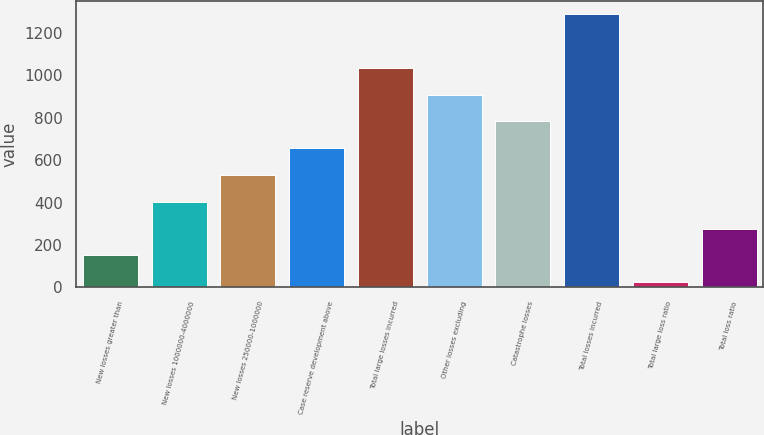<chart> <loc_0><loc_0><loc_500><loc_500><bar_chart><fcel>New losses greater than<fcel>New losses 1000000-4000000<fcel>New losses 250000-1000000<fcel>Case reserve development above<fcel>Total large losses incurred<fcel>Other losses excluding<fcel>Catastrophe losses<fcel>Total losses incurred<fcel>Total large loss ratio<fcel>Total loss ratio<nl><fcel>151.11<fcel>403.53<fcel>529.74<fcel>655.95<fcel>1034.58<fcel>908.37<fcel>782.16<fcel>1287<fcel>24.9<fcel>277.32<nl></chart> 